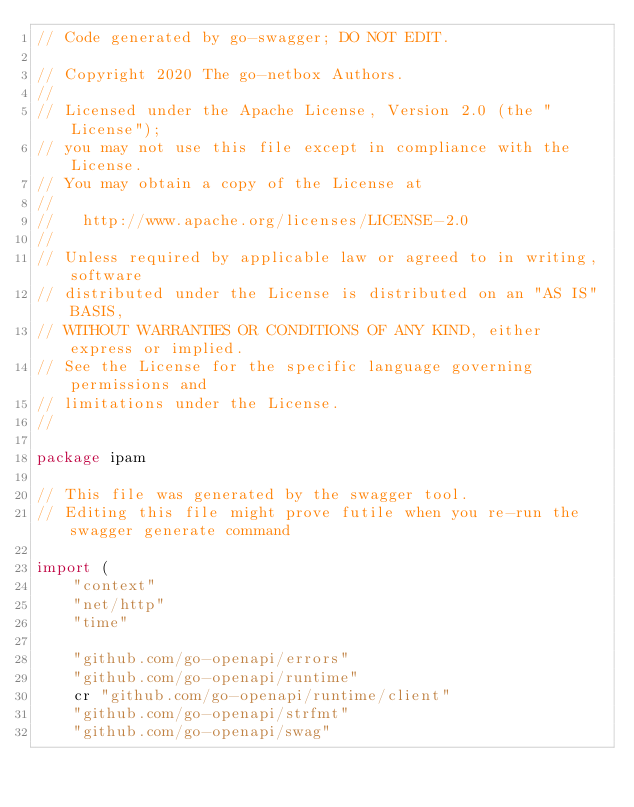Convert code to text. <code><loc_0><loc_0><loc_500><loc_500><_Go_>// Code generated by go-swagger; DO NOT EDIT.

// Copyright 2020 The go-netbox Authors.
//
// Licensed under the Apache License, Version 2.0 (the "License");
// you may not use this file except in compliance with the License.
// You may obtain a copy of the License at
//
//   http://www.apache.org/licenses/LICENSE-2.0
//
// Unless required by applicable law or agreed to in writing, software
// distributed under the License is distributed on an "AS IS" BASIS,
// WITHOUT WARRANTIES OR CONDITIONS OF ANY KIND, either express or implied.
// See the License for the specific language governing permissions and
// limitations under the License.
//

package ipam

// This file was generated by the swagger tool.
// Editing this file might prove futile when you re-run the swagger generate command

import (
	"context"
	"net/http"
	"time"

	"github.com/go-openapi/errors"
	"github.com/go-openapi/runtime"
	cr "github.com/go-openapi/runtime/client"
	"github.com/go-openapi/strfmt"
	"github.com/go-openapi/swag"
</code> 